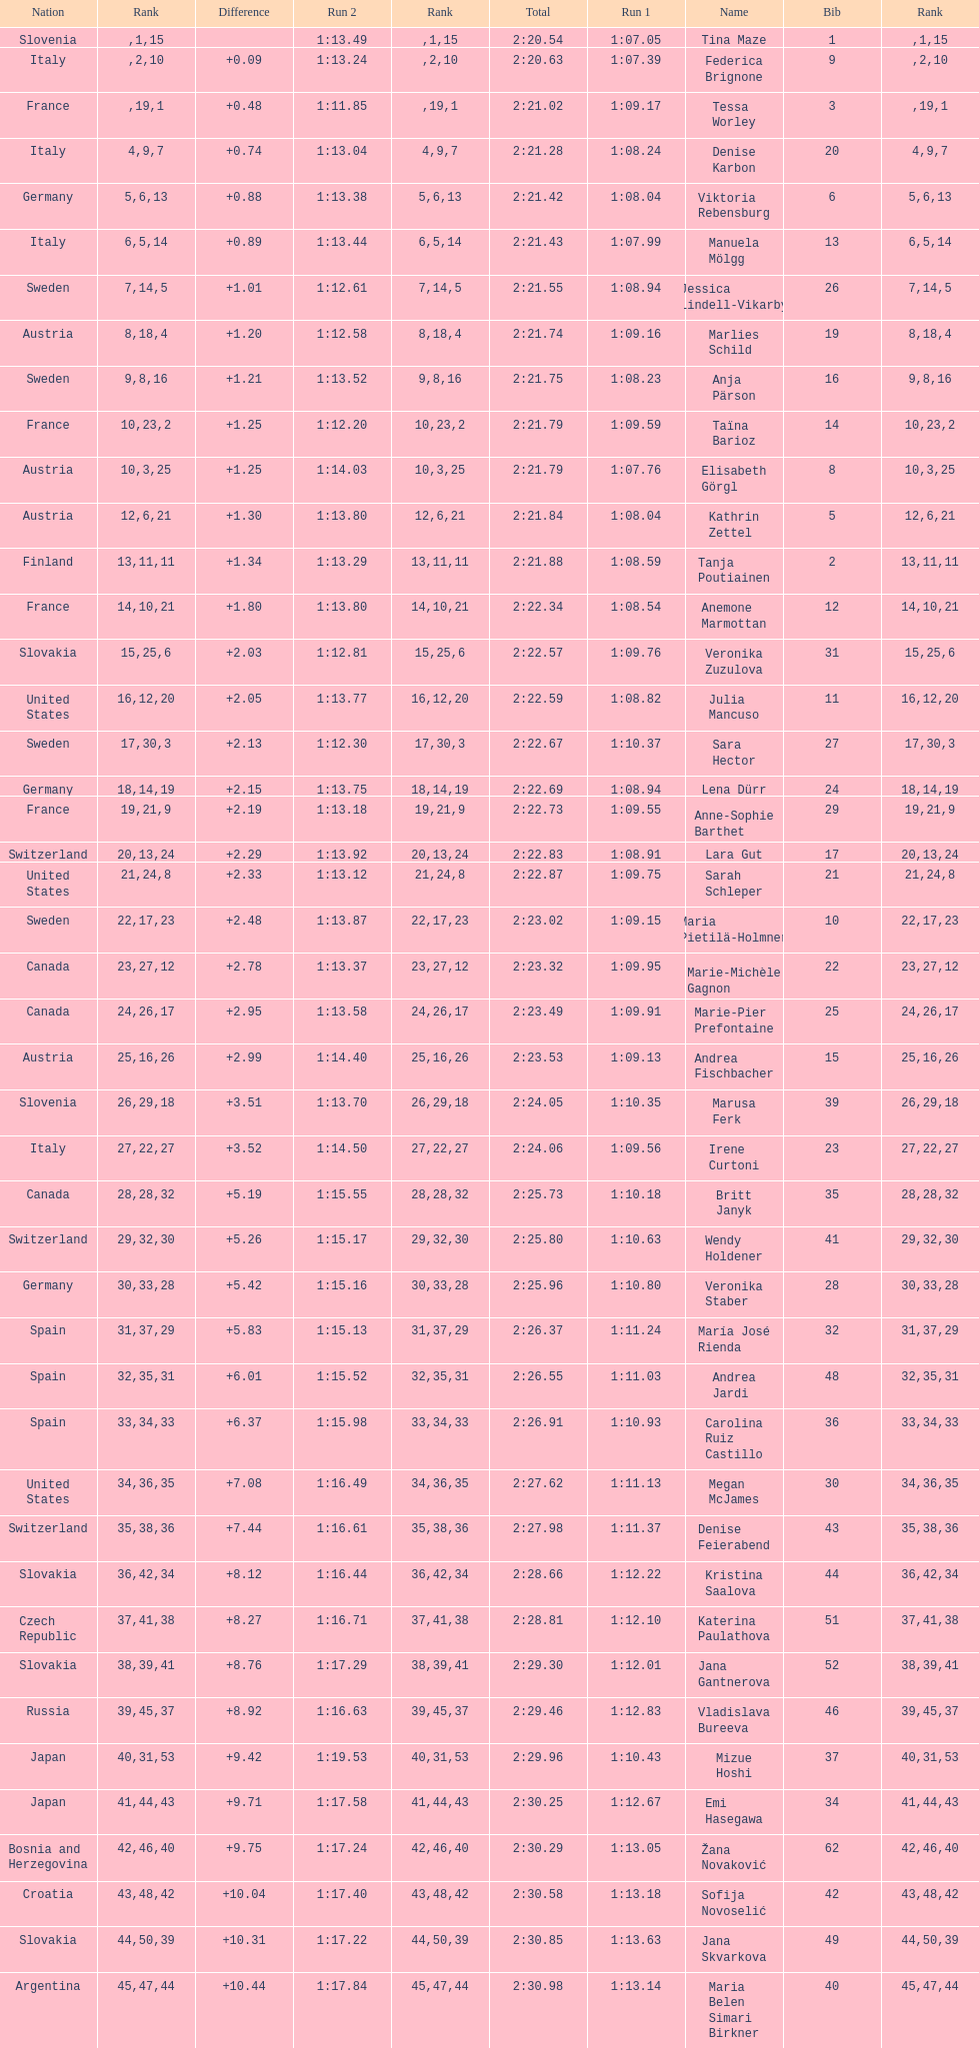How many athletes had the same rank for both run 1 and run 2? 1. 